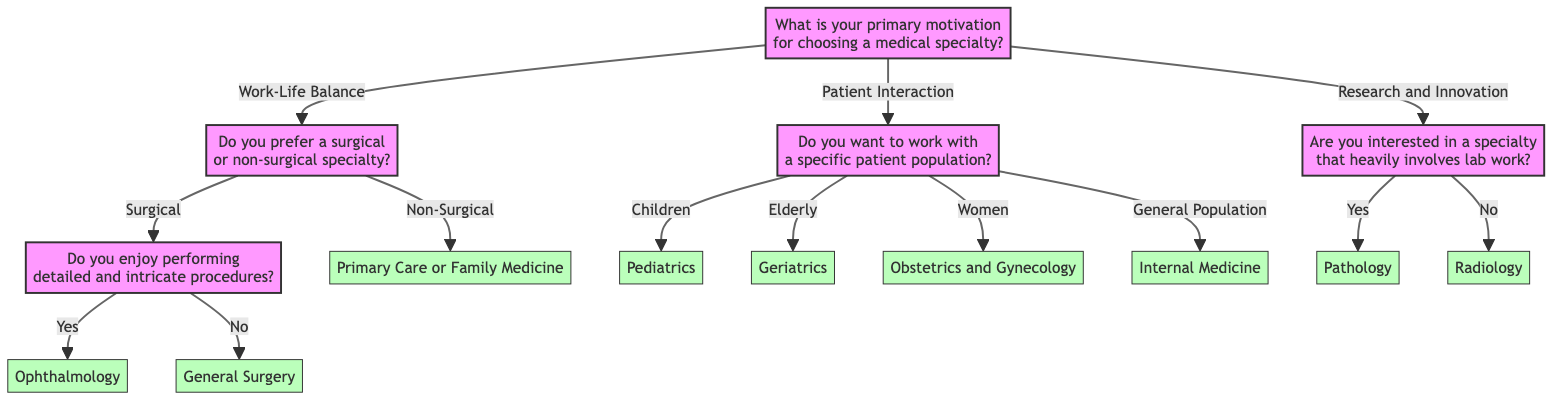What is the primary motivation for choosing a medical specialty in this diagram? The diagram starts with a single question about the primary motivation for choosing a medical specialty, which is clearly stated at the top of the flowchart.
Answer: Work-Life Balance, Patient Interaction, Research and Innovation What specialty follows if you prefer a non-surgical specialty? In the diagram, if the answer to the "Do you prefer a surgical or non-surgical specialty?" is "Non-Surgical," it leads directly to "Primary Care or Family Medicine."
Answer: Primary Care or Family Medicine How many main motivations are presented in the diagram? The decision tree presents three main motivations at the first decision node: Work-Life Balance, Patient Interaction, and Research and Innovation. Counting these gives us three distinct options.
Answer: 3 What specialty can you choose if you prefer working with children? The diagram shows that if the answer to "Do you want to work with a specific patient population?" is "Children," the result is "Pediatrics."
Answer: Pediatrics If someone enjoys detailed procedures and prefers a surgical specialty, what is the outcome? Following the "Work-Life Balance" and then choosing "Surgical," the next question asks if they enjoy performing detailed and intricate procedures. If they answer "Yes," the outcome becomes "Ophthalmology."
Answer: Ophthalmology What is the final result if someone is interested in a specialty that does not involve lab work? If the response to "Are you interested in a specialty that heavily involves lab work?" is "No," the flow leads directly to "Radiology," thus being the final result if lab work is not a focus.
Answer: Radiology Which specialty is chosen for someone motivated by research who enjoys lab work? The flow demonstrates that if one is motivated by research and innovation and answers "Yes" to being interested in lab work, the outcome will be "Pathology."
Answer: Pathology What option is presented if the answer regarding a specific patient population is "General Population"? The decision tree indicates that if "General Population" is selected in the patient population question, it leads directly to "Internal Medicine."
Answer: Internal Medicine What is the answer if someone prefers a surgical specialty but does not enjoy intricate procedures? The diagram shows that if you answer "Surgical" followed by "No" to enjoying detailed and intricate procedures, the result is "General Surgery."
Answer: General Surgery 